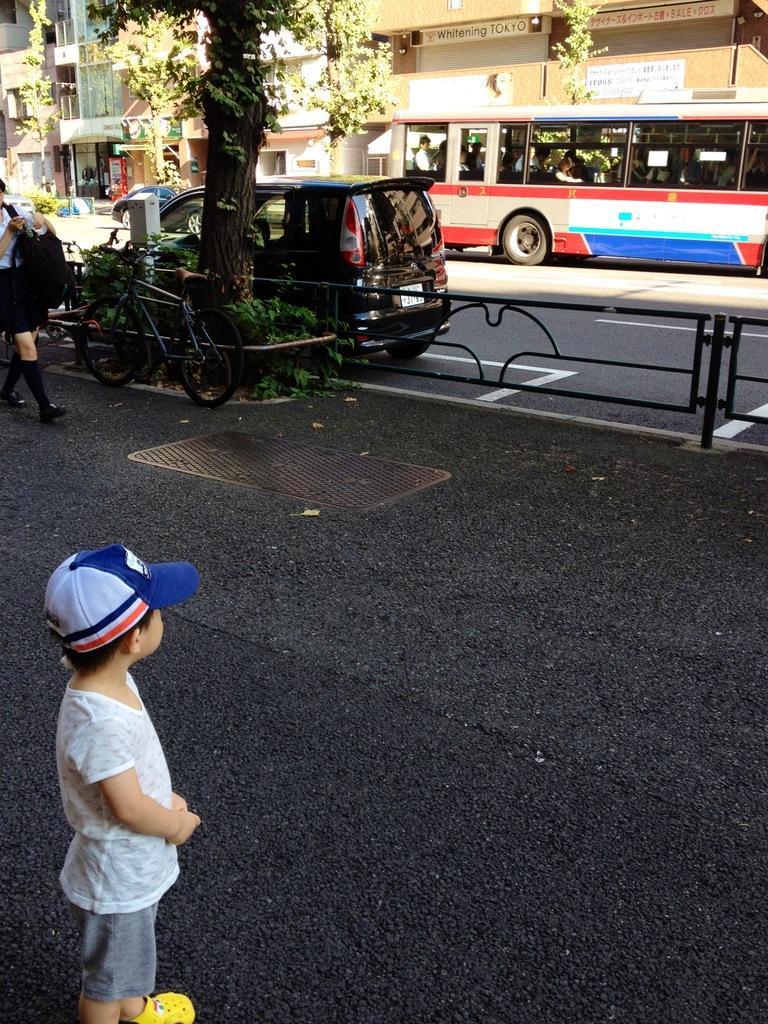Can you describe this image briefly? On the left side of the image we can see a boy standing. In the background there is a car and a bus on the road. We can see buildings. In the center there is a tree and a bicycle. We can see a fence. There is a person walking on the road. 